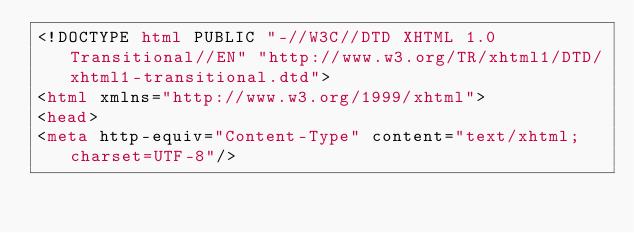<code> <loc_0><loc_0><loc_500><loc_500><_HTML_><!DOCTYPE html PUBLIC "-//W3C//DTD XHTML 1.0 Transitional//EN" "http://www.w3.org/TR/xhtml1/DTD/xhtml1-transitional.dtd">
<html xmlns="http://www.w3.org/1999/xhtml">
<head>
<meta http-equiv="Content-Type" content="text/xhtml;charset=UTF-8"/></code> 